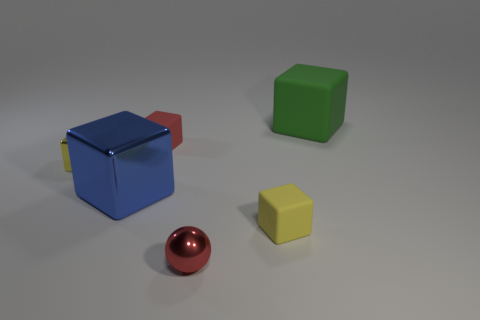What is the shape of the big thing that is left of the big green object?
Provide a succinct answer. Cube. Is the number of small cubes less than the number of tiny red rubber things?
Provide a succinct answer. No. Is there anything else of the same color as the large metallic object?
Make the answer very short. No. There is a yellow object that is left of the red block; what is its size?
Provide a succinct answer. Small. Are there more blue metal objects than large red spheres?
Provide a short and direct response. Yes. What material is the small red block?
Your answer should be very brief. Rubber. How many other objects are the same material as the large green cube?
Provide a succinct answer. 2. How many blue balls are there?
Provide a short and direct response. 0. There is a large blue thing that is the same shape as the large green thing; what is it made of?
Your answer should be compact. Metal. Is the big block that is to the left of the big green rubber thing made of the same material as the ball?
Offer a very short reply. Yes. 